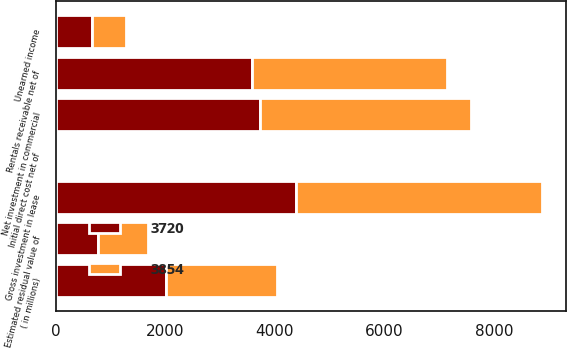Convert chart. <chart><loc_0><loc_0><loc_500><loc_500><stacked_bar_chart><ecel><fcel>( in millions)<fcel>Rentals receivable net of<fcel>Estimated residual value of<fcel>Initial direct cost net of<fcel>Gross investment in lease<fcel>Unearned income<fcel>Net investment in commercial<nl><fcel>3854<fcel>2015<fcel>3550<fcel>906<fcel>22<fcel>4478<fcel>624<fcel>3854<nl><fcel>3720<fcel>2014<fcel>3589<fcel>779<fcel>17<fcel>4385<fcel>665<fcel>3720<nl></chart> 